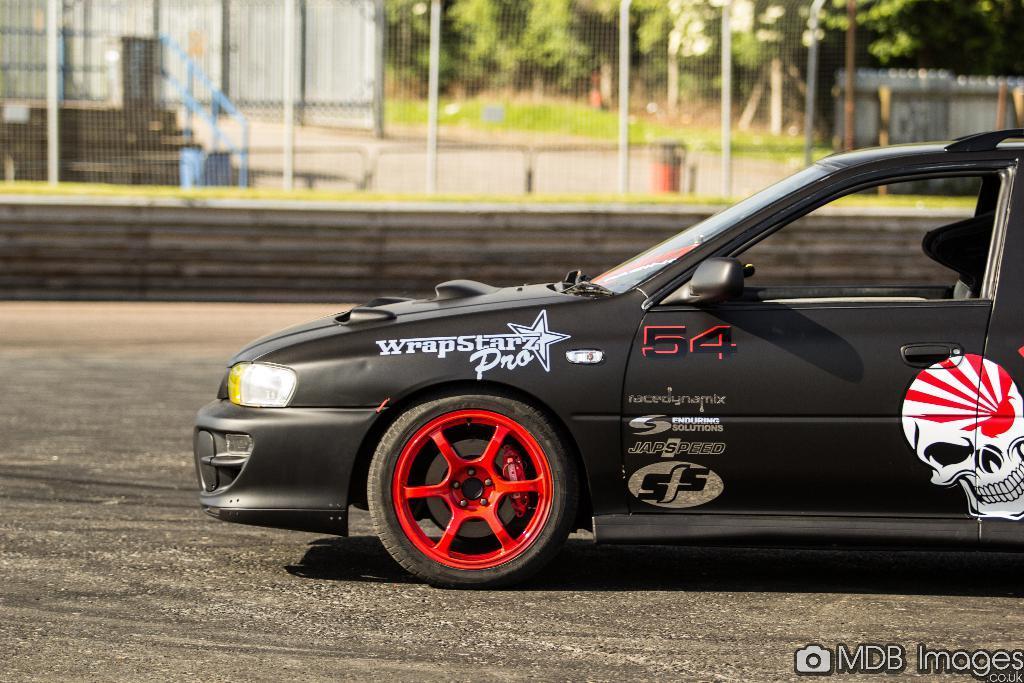Describe this image in one or two sentences. In the center of the image we can see a car on the road. In the background we can see fencing, trees and grass. 